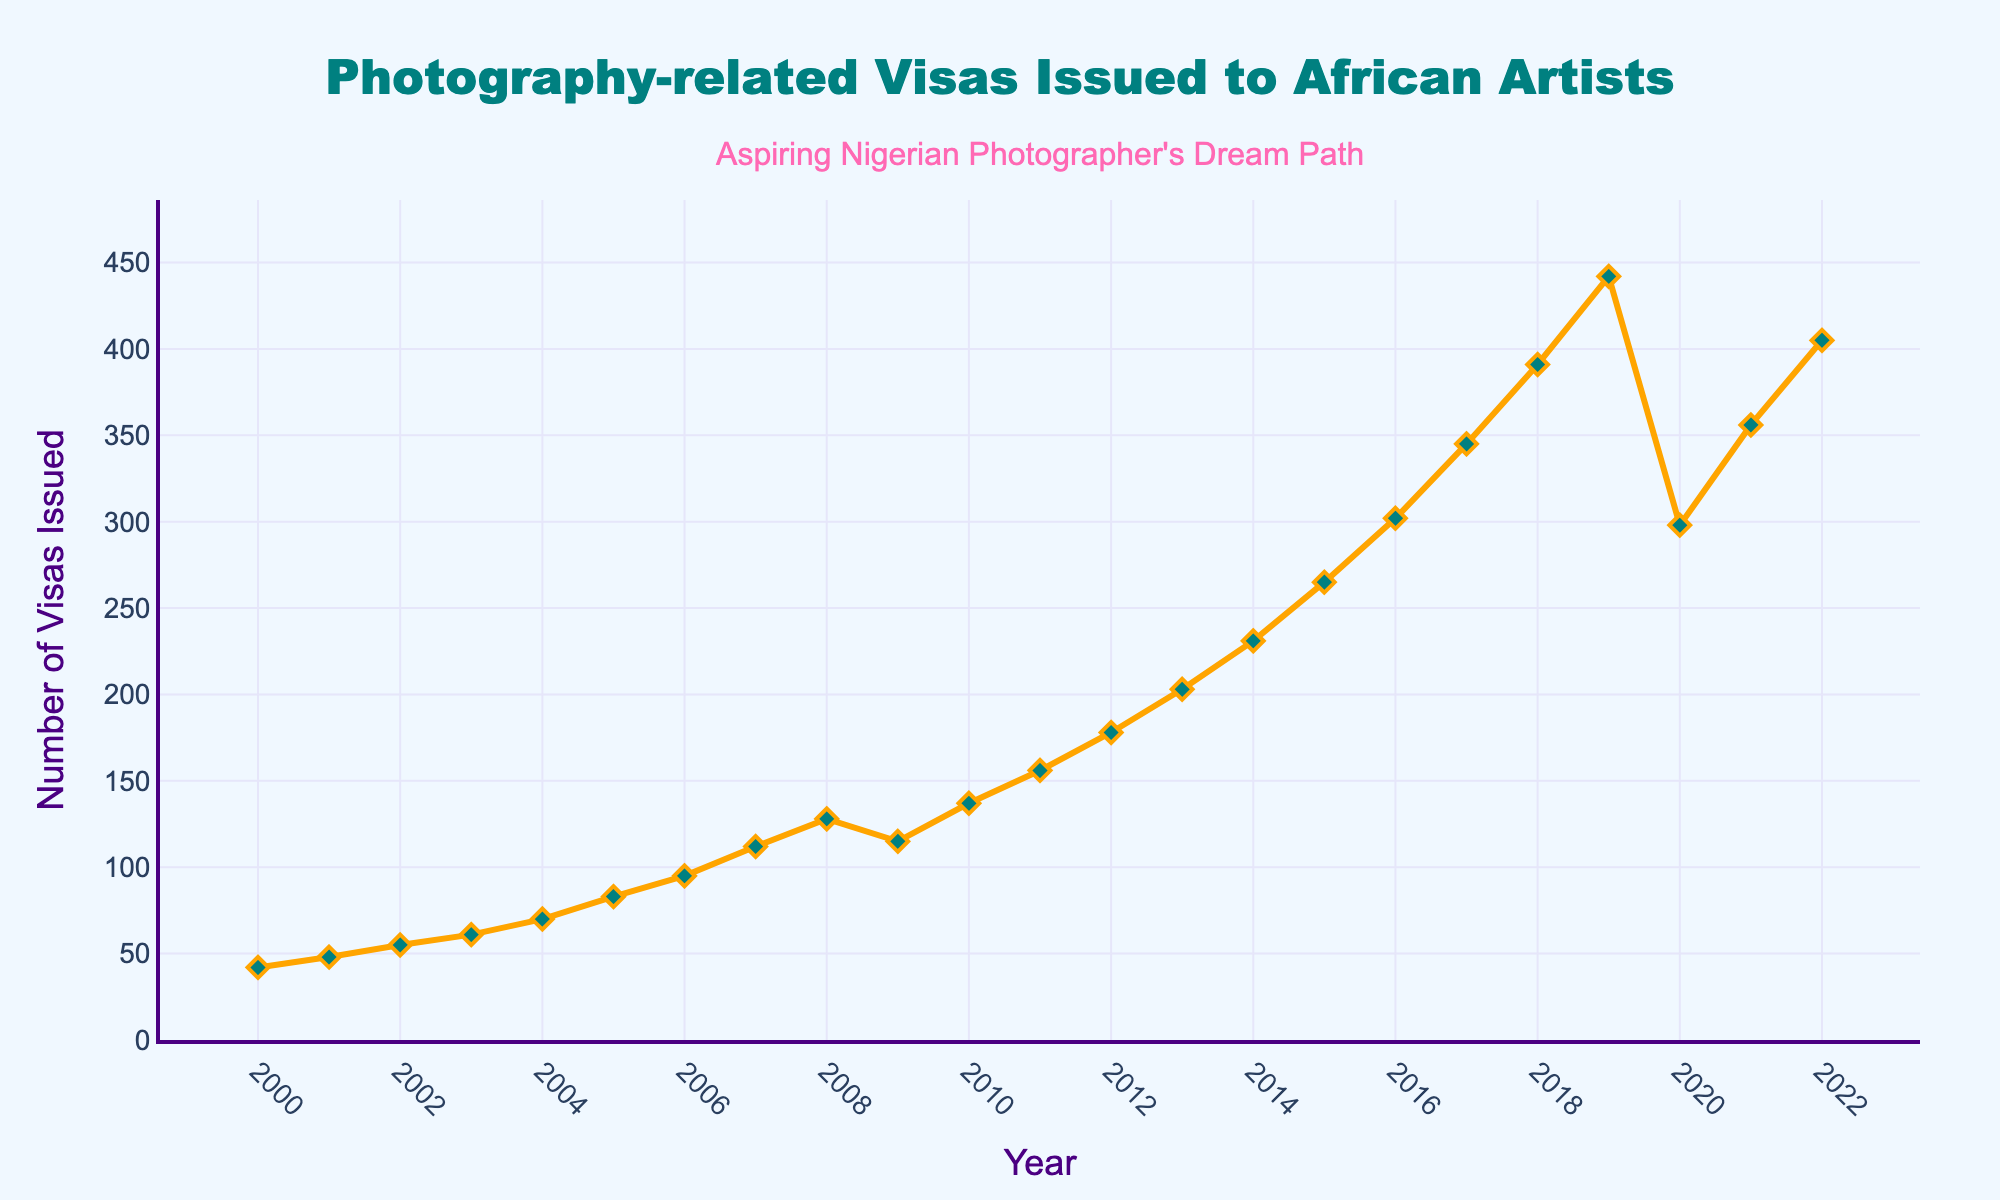What year saw the highest number of photography-related visas issued to African artists? The peak value in the line chart is the highest data point. By checking the highest point on the plot, we see that 2019 had the highest number of visas issued.
Answer: 2019 How did the number of visas issued change between 2008 and 2009? In 2008, 128 visas were issued, while in 2009, 115 visas were issued. To find the change, subtract the number of visas in 2009 from that in 2008: 128 - 115 = 13 (decrease).
Answer: Decreased by 13 What is the overall trend observed in the number of visas issued from 2000 to 2022? From 2000 to 2019, the trend consistently increases. There's a dip in 2020 followed by a rise again in 2021 and 2022. This indicates overall growth with a slight decline due to an unusual event around 2020.
Answer: Increasing trend Compare the number of visas issued in 2005 and 2010. Which year had more visas issued and by how much? In 2005, 83 visas were issued, and in 2010, 137 visas were issued. 137 - 83 = 54. Therefore, 2010 had 54 more visas issued than 2005.
Answer: 2010 by 54 What was the average number of visas issued from 2016 to 2019? Calculate the sum of visas issued from 2016 to 2019: 302 (2016) + 345 (2017) + 391 (2018) + 442 (2019) = 1480. Then, divide by the number of years: 1480 / 4 = 370
Answer: 370 How did the COVID-19 pandemic likely impact the number of visas issued in 2020? The data shows a significant drop from 2019 to 2020, from 442 to 298 visas issued. This indicates a decline by 144, likely due to pandemic-related travel restrictions and uncertainties.
Answer: Significant drop What was the rate of increase in the number of visas issued between the years 2014 and 2015? Visas issued in 2014 were 231 and in 2015 were 265. The rate of increase is calculated by (265 - 231) / 231 * 100% = 14.72%.
Answer: 14.72% During which year between 2000 and 2022 did the number of visas issued first exceed 200? By inspecting the plot, in 2013 the number of visas issued first exceeded 200, with a count of 203.
Answer: 2013 